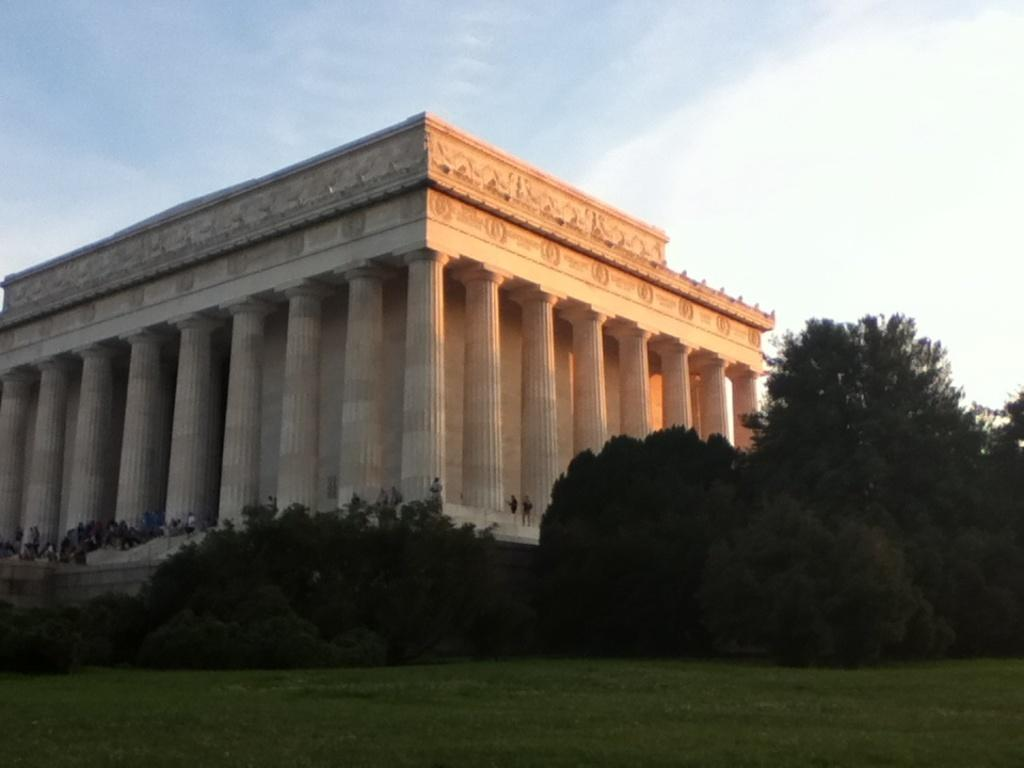What is the main subject in the center of the image? There is a building and persons in the center of the image. What type of vegetation is visible at the bottom of the image? Trees and grass are present at the bottom of the image. What can be seen in the background of the image? There are clouds and the sky visible in the background of the image. What type of curtain can be seen hanging from the building in the image? There is no curtain visible hanging from the building in the image. How does the cork float on the river in the image? There is no river or cork present in the image. 